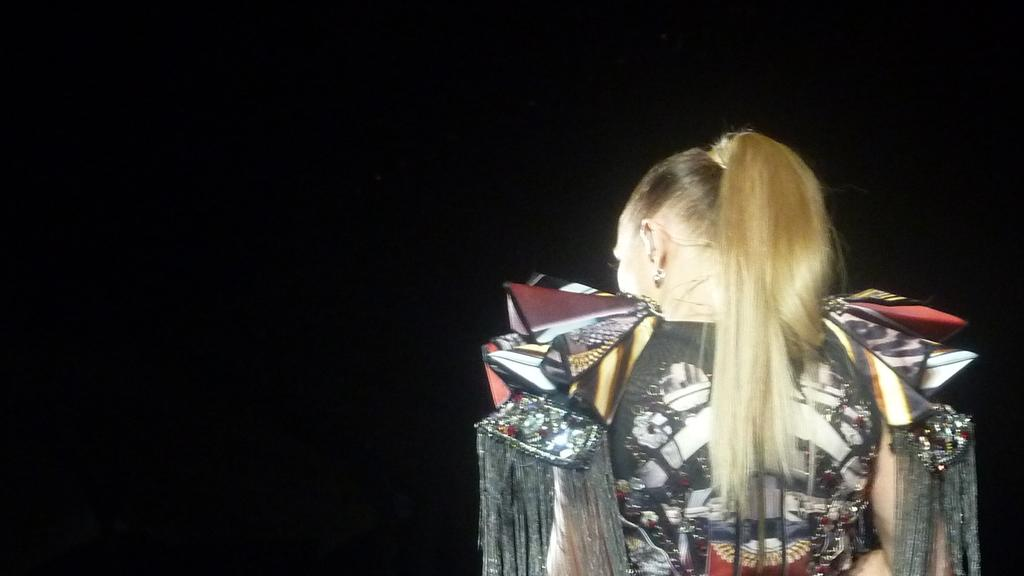What is the main subject of the image? There is a lady standing in the image. Can you describe the background of the image? The background of the image is dark. What is the name of the boat in the cemetery in the image? There is no boat or cemetery present in the image; it features a lady standing with a dark background. 